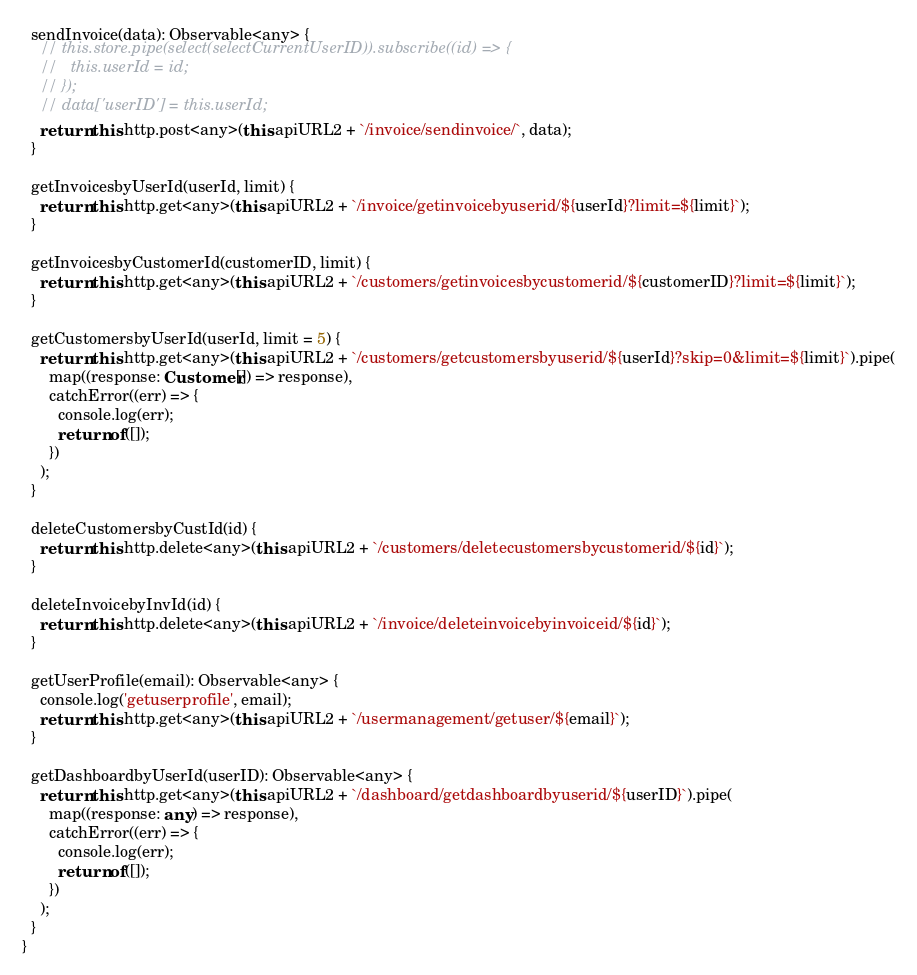Convert code to text. <code><loc_0><loc_0><loc_500><loc_500><_TypeScript_>  sendInvoice(data): Observable<any> {
    // this.store.pipe(select(selectCurrentUserID)).subscribe((id) => {
    //   this.userId = id;
    // });
    // data['userID'] = this.userId;
    return this.http.post<any>(this.apiURL2 + `/invoice/sendinvoice/`, data);
  }

  getInvoicesbyUserId(userId, limit) {
    return this.http.get<any>(this.apiURL2 + `/invoice/getinvoicebyuserid/${userId}?limit=${limit}`);
  }

  getInvoicesbyCustomerId(customerID, limit) {
    return this.http.get<any>(this.apiURL2 + `/customers/getinvoicesbycustomerid/${customerID}?limit=${limit}`);
  }

  getCustomersbyUserId(userId, limit = 5) {
    return this.http.get<any>(this.apiURL2 + `/customers/getcustomersbyuserid/${userId}?skip=0&limit=${limit}`).pipe(
      map((response: Customer[]) => response),
      catchError((err) => {
        console.log(err);
        return of([]);
      })
    );
  }

  deleteCustomersbyCustId(id) {
    return this.http.delete<any>(this.apiURL2 + `/customers/deletecustomersbycustomerid/${id}`);
  }

  deleteInvoicebyInvId(id) {
    return this.http.delete<any>(this.apiURL2 + `/invoice/deleteinvoicebyinvoiceid/${id}`);
  }

  getUserProfile(email): Observable<any> {
    console.log('getuserprofile', email);
    return this.http.get<any>(this.apiURL2 + `/usermanagement/getuser/${email}`);
  }

  getDashboardbyUserId(userID): Observable<any> {
    return this.http.get<any>(this.apiURL2 + `/dashboard/getdashboardbyuserid/${userID}`).pipe(
      map((response: any) => response),
      catchError((err) => {
        console.log(err);
        return of([]);
      })
    );
  }
}
</code> 